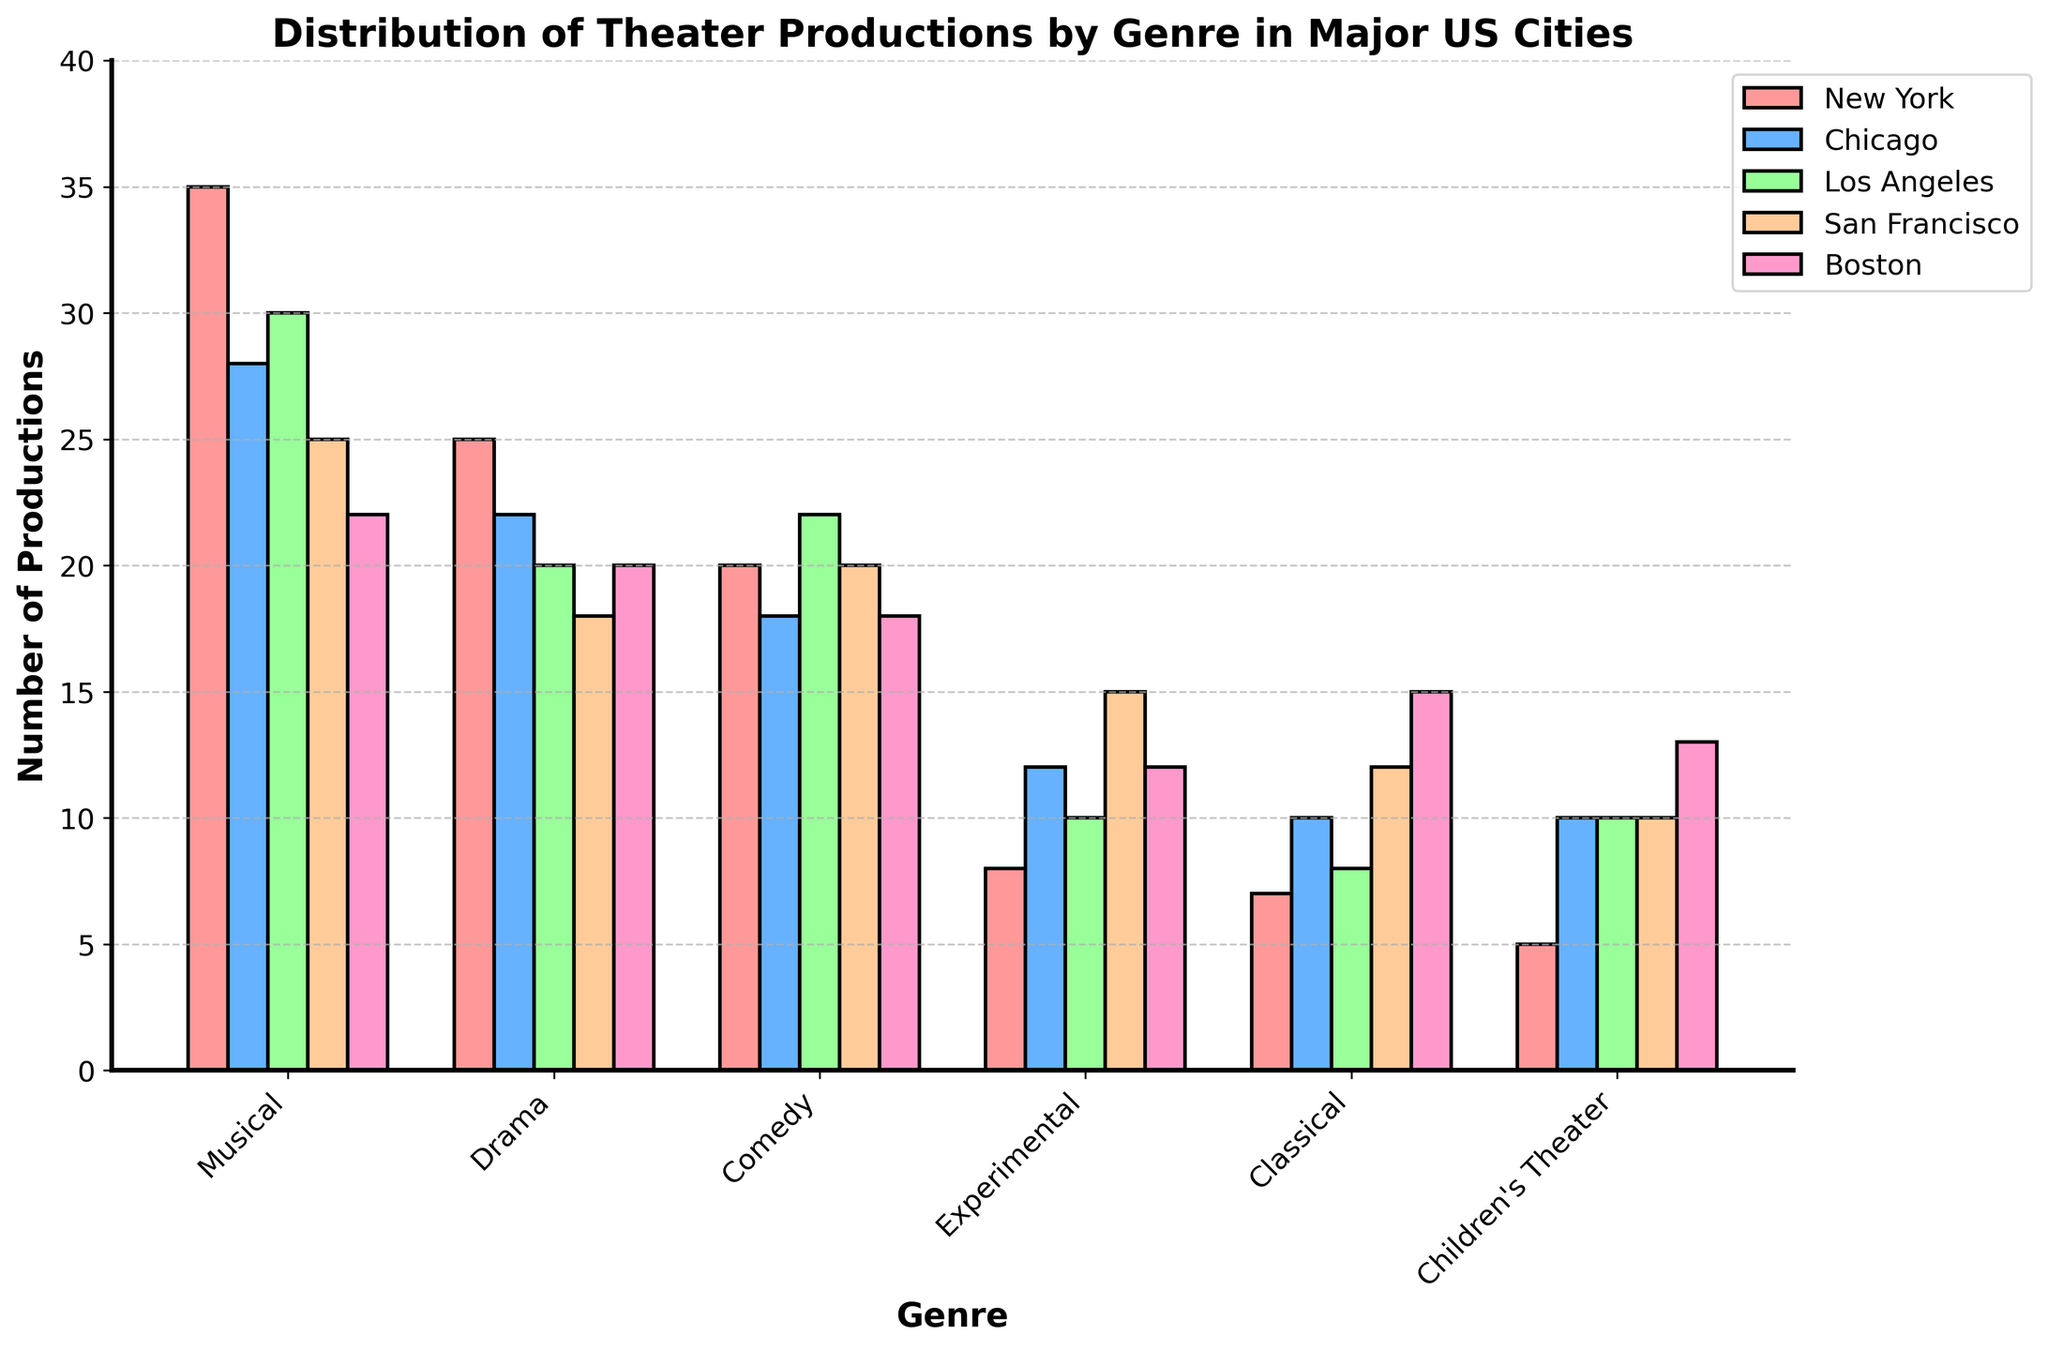Which city has the most musical productions? By looking at the height of the bars for the musical genre, New York clearly has the highest bar.
Answer: New York Which genre has the least number of productions in Boston? The bar for Children's Theater is the smallest in Boston.
Answer: Children's Theater How many more musical productions does New York have compared to Chicago? New York has 35 musical productions, and Chicago has 28. Thus, the difference is 35 - 28.
Answer: 7 What is the total number of comedy productions in New York, Chicago, and Los Angeles? Summing the comedy productions in these three cities: 20 (New York) + 18 (Chicago) + 22 (Los Angeles).
Answer: 60 Is the number of experimental productions higher in San Francisco or Los Angeles? By comparing the height of the experimental bars, San Francisco's bar is taller than Los Angeles's.
Answer: San Francisco Which genre has the highest number of productions in San Francisco? The musical genre has the highest bar in San Francisco.
Answer: Musical What is the average number of classical productions across all five cities? Summing up the classical productions (7 + 10 + 8 + 12 + 15) gives 52. Dividing by 5 cities, the average is 52 / 5.
Answer: 10.4 Comparing the number of children's theater productions, which city has the smallest number? By comparing the height of the bars for Children's Theater, New York has the smallest bar.
Answer: New York Are there more drama productions or children's theater productions in Chicago? Comparing the drama and children's theater bars in Chicago shows that the drama bar is taller.
Answer: Drama Which city has the most balanced distribution of productions across genres? San Francisco and Boston have more evenly sized bars across different genres, indicating a more balanced distribution.
Answer: San Francisco / Boston 